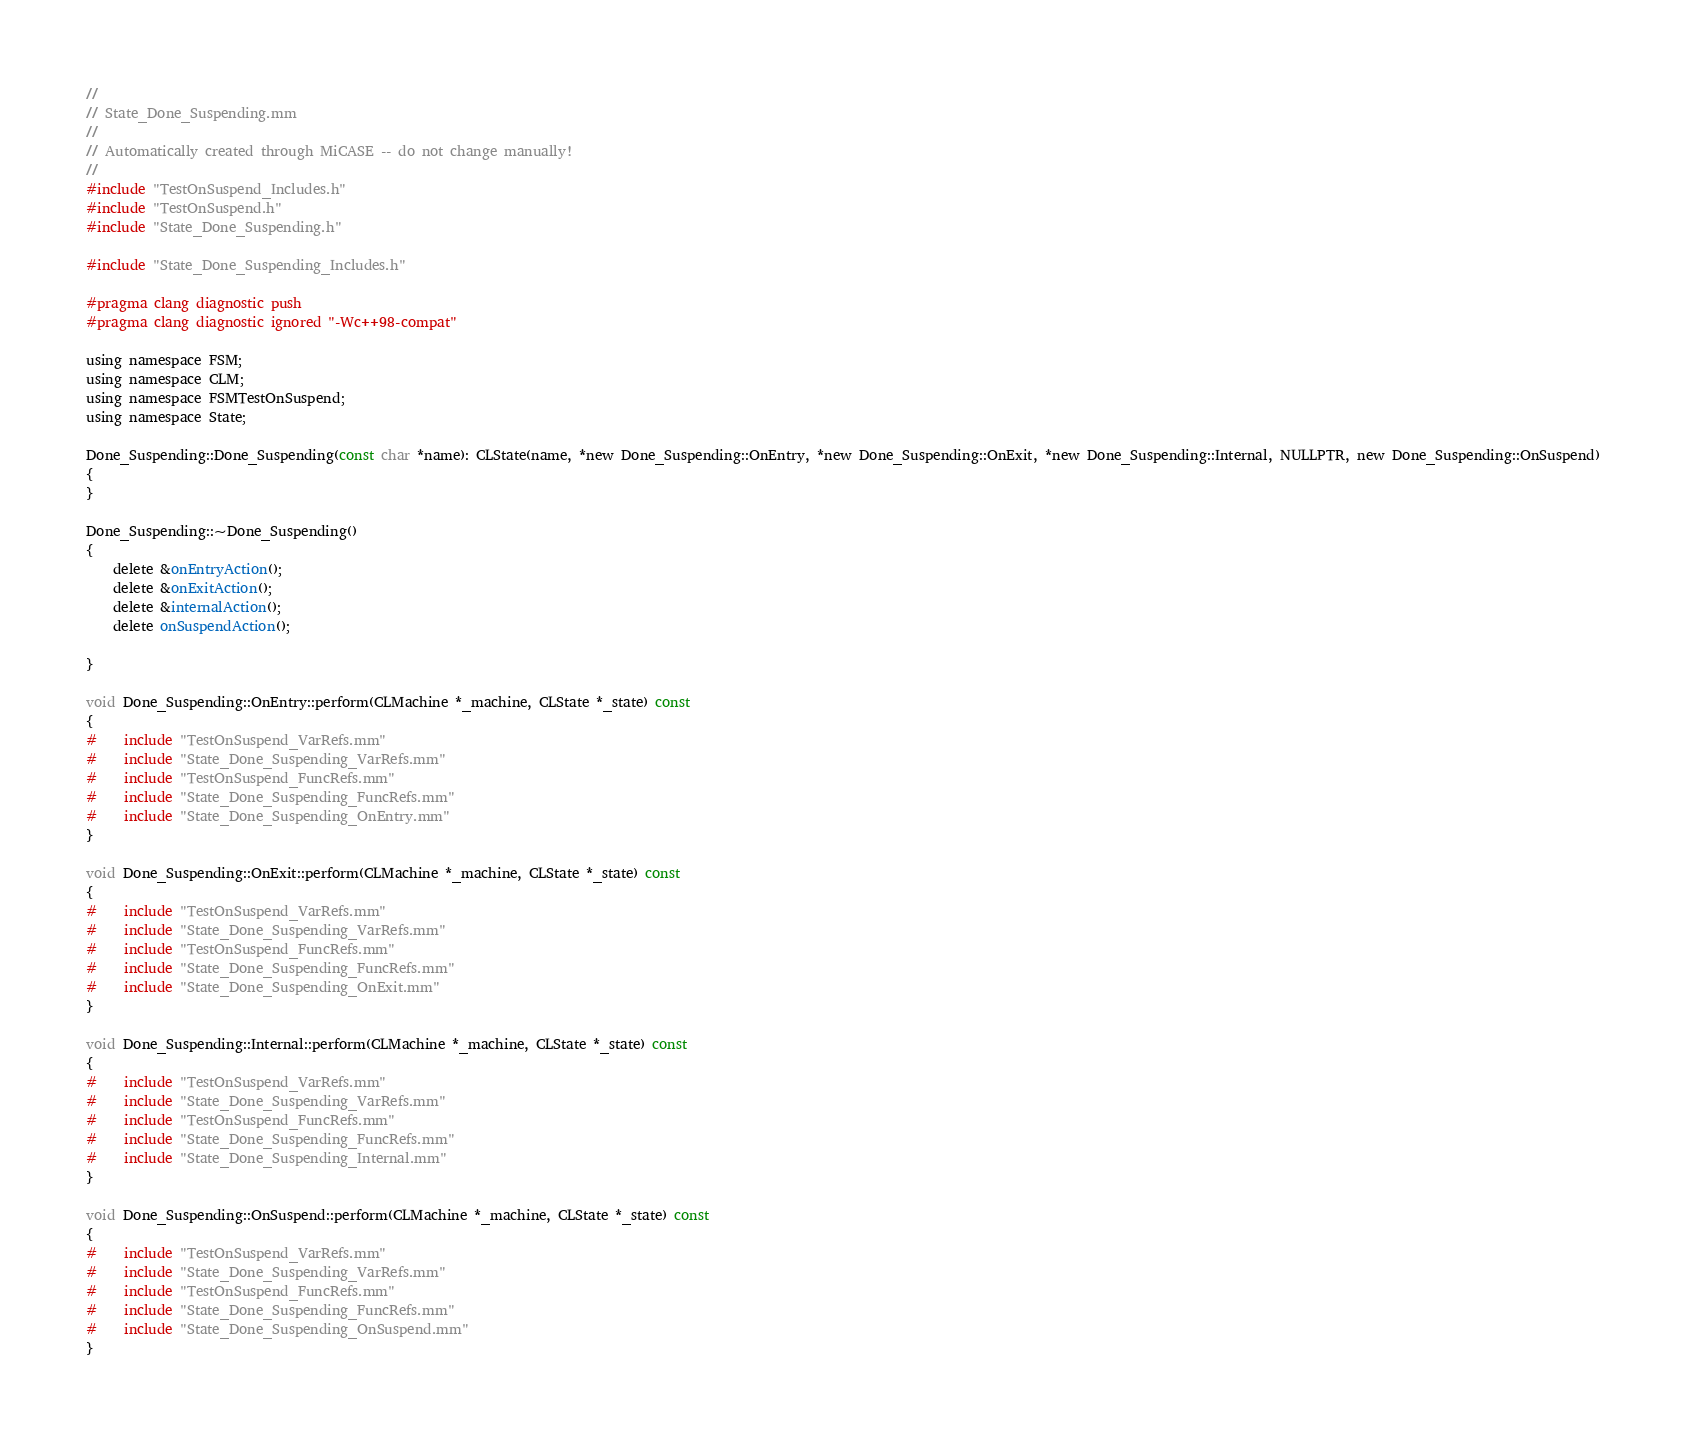<code> <loc_0><loc_0><loc_500><loc_500><_ObjectiveC_>//
// State_Done_Suspending.mm
//
// Automatically created through MiCASE -- do not change manually!
//
#include "TestOnSuspend_Includes.h"
#include "TestOnSuspend.h"
#include "State_Done_Suspending.h"

#include "State_Done_Suspending_Includes.h"

#pragma clang diagnostic push
#pragma clang diagnostic ignored "-Wc++98-compat"

using namespace FSM;
using namespace CLM;
using namespace FSMTestOnSuspend;
using namespace State;

Done_Suspending::Done_Suspending(const char *name): CLState(name, *new Done_Suspending::OnEntry, *new Done_Suspending::OnExit, *new Done_Suspending::Internal, NULLPTR, new Done_Suspending::OnSuspend)
{
}

Done_Suspending::~Done_Suspending()
{
	delete &onEntryAction();
	delete &onExitAction();
	delete &internalAction();
	delete onSuspendAction();

}

void Done_Suspending::OnEntry::perform(CLMachine *_machine, CLState *_state) const
{
#	include "TestOnSuspend_VarRefs.mm"
#	include "State_Done_Suspending_VarRefs.mm"
#	include "TestOnSuspend_FuncRefs.mm"
#	include "State_Done_Suspending_FuncRefs.mm"
#	include "State_Done_Suspending_OnEntry.mm"
}

void Done_Suspending::OnExit::perform(CLMachine *_machine, CLState *_state) const
{
#	include "TestOnSuspend_VarRefs.mm"
#	include "State_Done_Suspending_VarRefs.mm"
#	include "TestOnSuspend_FuncRefs.mm"
#	include "State_Done_Suspending_FuncRefs.mm"
#	include "State_Done_Suspending_OnExit.mm"
}

void Done_Suspending::Internal::perform(CLMachine *_machine, CLState *_state) const
{
#	include "TestOnSuspend_VarRefs.mm"
#	include "State_Done_Suspending_VarRefs.mm"
#	include "TestOnSuspend_FuncRefs.mm"
#	include "State_Done_Suspending_FuncRefs.mm"
#	include "State_Done_Suspending_Internal.mm"
}

void Done_Suspending::OnSuspend::perform(CLMachine *_machine, CLState *_state) const
{
#	include "TestOnSuspend_VarRefs.mm"
#	include "State_Done_Suspending_VarRefs.mm"
#	include "TestOnSuspend_FuncRefs.mm"
#	include "State_Done_Suspending_FuncRefs.mm"
#	include "State_Done_Suspending_OnSuspend.mm"
}
</code> 